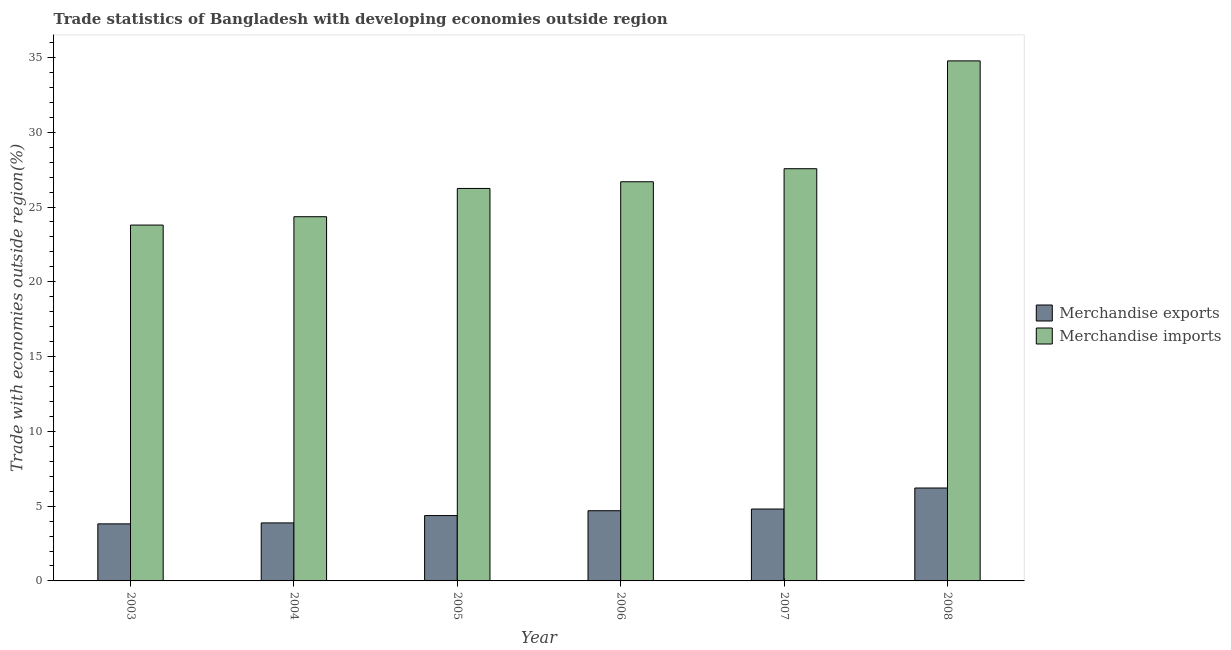How many different coloured bars are there?
Give a very brief answer. 2. Are the number of bars per tick equal to the number of legend labels?
Your response must be concise. Yes. Are the number of bars on each tick of the X-axis equal?
Keep it short and to the point. Yes. What is the merchandise imports in 2005?
Ensure brevity in your answer.  26.24. Across all years, what is the maximum merchandise imports?
Your response must be concise. 34.77. Across all years, what is the minimum merchandise imports?
Give a very brief answer. 23.79. In which year was the merchandise exports minimum?
Give a very brief answer. 2003. What is the total merchandise exports in the graph?
Offer a very short reply. 27.77. What is the difference between the merchandise imports in 2006 and that in 2007?
Offer a very short reply. -0.87. What is the difference between the merchandise exports in 2005 and the merchandise imports in 2007?
Offer a terse response. -0.44. What is the average merchandise exports per year?
Your answer should be compact. 4.63. What is the ratio of the merchandise exports in 2004 to that in 2008?
Make the answer very short. 0.62. Is the merchandise imports in 2004 less than that in 2007?
Make the answer very short. Yes. Is the difference between the merchandise exports in 2004 and 2007 greater than the difference between the merchandise imports in 2004 and 2007?
Keep it short and to the point. No. What is the difference between the highest and the second highest merchandise exports?
Provide a succinct answer. 1.41. What is the difference between the highest and the lowest merchandise imports?
Your answer should be compact. 10.98. How many bars are there?
Offer a very short reply. 12. Are all the bars in the graph horizontal?
Keep it short and to the point. No. How many years are there in the graph?
Offer a very short reply. 6. What is the difference between two consecutive major ticks on the Y-axis?
Offer a terse response. 5. Does the graph contain grids?
Offer a terse response. No. Where does the legend appear in the graph?
Your response must be concise. Center right. What is the title of the graph?
Your answer should be compact. Trade statistics of Bangladesh with developing economies outside region. Does "Male labourers" appear as one of the legend labels in the graph?
Keep it short and to the point. No. What is the label or title of the Y-axis?
Provide a short and direct response. Trade with economies outside region(%). What is the Trade with economies outside region(%) in Merchandise exports in 2003?
Ensure brevity in your answer.  3.81. What is the Trade with economies outside region(%) of Merchandise imports in 2003?
Give a very brief answer. 23.79. What is the Trade with economies outside region(%) of Merchandise exports in 2004?
Your response must be concise. 3.88. What is the Trade with economies outside region(%) of Merchandise imports in 2004?
Ensure brevity in your answer.  24.35. What is the Trade with economies outside region(%) of Merchandise exports in 2005?
Your response must be concise. 4.37. What is the Trade with economies outside region(%) in Merchandise imports in 2005?
Your response must be concise. 26.24. What is the Trade with economies outside region(%) of Merchandise exports in 2006?
Your answer should be very brief. 4.69. What is the Trade with economies outside region(%) in Merchandise imports in 2006?
Your answer should be compact. 26.69. What is the Trade with economies outside region(%) in Merchandise exports in 2007?
Keep it short and to the point. 4.81. What is the Trade with economies outside region(%) in Merchandise imports in 2007?
Your answer should be very brief. 27.56. What is the Trade with economies outside region(%) of Merchandise exports in 2008?
Make the answer very short. 6.21. What is the Trade with economies outside region(%) of Merchandise imports in 2008?
Offer a very short reply. 34.77. Across all years, what is the maximum Trade with economies outside region(%) of Merchandise exports?
Offer a terse response. 6.21. Across all years, what is the maximum Trade with economies outside region(%) in Merchandise imports?
Provide a succinct answer. 34.77. Across all years, what is the minimum Trade with economies outside region(%) of Merchandise exports?
Your answer should be very brief. 3.81. Across all years, what is the minimum Trade with economies outside region(%) of Merchandise imports?
Give a very brief answer. 23.79. What is the total Trade with economies outside region(%) in Merchandise exports in the graph?
Offer a very short reply. 27.77. What is the total Trade with economies outside region(%) in Merchandise imports in the graph?
Your answer should be compact. 163.4. What is the difference between the Trade with economies outside region(%) in Merchandise exports in 2003 and that in 2004?
Give a very brief answer. -0.06. What is the difference between the Trade with economies outside region(%) of Merchandise imports in 2003 and that in 2004?
Your response must be concise. -0.56. What is the difference between the Trade with economies outside region(%) of Merchandise exports in 2003 and that in 2005?
Your response must be concise. -0.56. What is the difference between the Trade with economies outside region(%) in Merchandise imports in 2003 and that in 2005?
Keep it short and to the point. -2.45. What is the difference between the Trade with economies outside region(%) in Merchandise exports in 2003 and that in 2006?
Keep it short and to the point. -0.88. What is the difference between the Trade with economies outside region(%) in Merchandise imports in 2003 and that in 2006?
Offer a very short reply. -2.9. What is the difference between the Trade with economies outside region(%) in Merchandise exports in 2003 and that in 2007?
Your answer should be very brief. -0.99. What is the difference between the Trade with economies outside region(%) in Merchandise imports in 2003 and that in 2007?
Ensure brevity in your answer.  -3.77. What is the difference between the Trade with economies outside region(%) of Merchandise exports in 2003 and that in 2008?
Your answer should be very brief. -2.4. What is the difference between the Trade with economies outside region(%) of Merchandise imports in 2003 and that in 2008?
Your answer should be compact. -10.98. What is the difference between the Trade with economies outside region(%) of Merchandise exports in 2004 and that in 2005?
Keep it short and to the point. -0.49. What is the difference between the Trade with economies outside region(%) of Merchandise imports in 2004 and that in 2005?
Give a very brief answer. -1.89. What is the difference between the Trade with economies outside region(%) of Merchandise exports in 2004 and that in 2006?
Provide a short and direct response. -0.81. What is the difference between the Trade with economies outside region(%) in Merchandise imports in 2004 and that in 2006?
Your answer should be very brief. -2.34. What is the difference between the Trade with economies outside region(%) of Merchandise exports in 2004 and that in 2007?
Your answer should be compact. -0.93. What is the difference between the Trade with economies outside region(%) in Merchandise imports in 2004 and that in 2007?
Your answer should be very brief. -3.21. What is the difference between the Trade with economies outside region(%) in Merchandise exports in 2004 and that in 2008?
Offer a very short reply. -2.33. What is the difference between the Trade with economies outside region(%) of Merchandise imports in 2004 and that in 2008?
Keep it short and to the point. -10.42. What is the difference between the Trade with economies outside region(%) in Merchandise exports in 2005 and that in 2006?
Offer a terse response. -0.32. What is the difference between the Trade with economies outside region(%) in Merchandise imports in 2005 and that in 2006?
Your answer should be compact. -0.45. What is the difference between the Trade with economies outside region(%) of Merchandise exports in 2005 and that in 2007?
Your answer should be very brief. -0.44. What is the difference between the Trade with economies outside region(%) in Merchandise imports in 2005 and that in 2007?
Give a very brief answer. -1.32. What is the difference between the Trade with economies outside region(%) of Merchandise exports in 2005 and that in 2008?
Provide a succinct answer. -1.84. What is the difference between the Trade with economies outside region(%) of Merchandise imports in 2005 and that in 2008?
Ensure brevity in your answer.  -8.53. What is the difference between the Trade with economies outside region(%) in Merchandise exports in 2006 and that in 2007?
Offer a terse response. -0.11. What is the difference between the Trade with economies outside region(%) in Merchandise imports in 2006 and that in 2007?
Keep it short and to the point. -0.87. What is the difference between the Trade with economies outside region(%) of Merchandise exports in 2006 and that in 2008?
Offer a terse response. -1.52. What is the difference between the Trade with economies outside region(%) of Merchandise imports in 2006 and that in 2008?
Your response must be concise. -8.08. What is the difference between the Trade with economies outside region(%) of Merchandise exports in 2007 and that in 2008?
Keep it short and to the point. -1.41. What is the difference between the Trade with economies outside region(%) in Merchandise imports in 2007 and that in 2008?
Ensure brevity in your answer.  -7.21. What is the difference between the Trade with economies outside region(%) in Merchandise exports in 2003 and the Trade with economies outside region(%) in Merchandise imports in 2004?
Keep it short and to the point. -20.54. What is the difference between the Trade with economies outside region(%) of Merchandise exports in 2003 and the Trade with economies outside region(%) of Merchandise imports in 2005?
Give a very brief answer. -22.43. What is the difference between the Trade with economies outside region(%) of Merchandise exports in 2003 and the Trade with economies outside region(%) of Merchandise imports in 2006?
Your answer should be very brief. -22.87. What is the difference between the Trade with economies outside region(%) of Merchandise exports in 2003 and the Trade with economies outside region(%) of Merchandise imports in 2007?
Your answer should be compact. -23.75. What is the difference between the Trade with economies outside region(%) of Merchandise exports in 2003 and the Trade with economies outside region(%) of Merchandise imports in 2008?
Your answer should be very brief. -30.96. What is the difference between the Trade with economies outside region(%) in Merchandise exports in 2004 and the Trade with economies outside region(%) in Merchandise imports in 2005?
Offer a terse response. -22.36. What is the difference between the Trade with economies outside region(%) of Merchandise exports in 2004 and the Trade with economies outside region(%) of Merchandise imports in 2006?
Keep it short and to the point. -22.81. What is the difference between the Trade with economies outside region(%) in Merchandise exports in 2004 and the Trade with economies outside region(%) in Merchandise imports in 2007?
Give a very brief answer. -23.68. What is the difference between the Trade with economies outside region(%) in Merchandise exports in 2004 and the Trade with economies outside region(%) in Merchandise imports in 2008?
Make the answer very short. -30.89. What is the difference between the Trade with economies outside region(%) of Merchandise exports in 2005 and the Trade with economies outside region(%) of Merchandise imports in 2006?
Offer a very short reply. -22.32. What is the difference between the Trade with economies outside region(%) of Merchandise exports in 2005 and the Trade with economies outside region(%) of Merchandise imports in 2007?
Offer a very short reply. -23.19. What is the difference between the Trade with economies outside region(%) of Merchandise exports in 2005 and the Trade with economies outside region(%) of Merchandise imports in 2008?
Your answer should be compact. -30.4. What is the difference between the Trade with economies outside region(%) in Merchandise exports in 2006 and the Trade with economies outside region(%) in Merchandise imports in 2007?
Offer a terse response. -22.87. What is the difference between the Trade with economies outside region(%) of Merchandise exports in 2006 and the Trade with economies outside region(%) of Merchandise imports in 2008?
Offer a very short reply. -30.08. What is the difference between the Trade with economies outside region(%) of Merchandise exports in 2007 and the Trade with economies outside region(%) of Merchandise imports in 2008?
Your answer should be compact. -29.96. What is the average Trade with economies outside region(%) of Merchandise exports per year?
Your answer should be compact. 4.63. What is the average Trade with economies outside region(%) of Merchandise imports per year?
Your response must be concise. 27.23. In the year 2003, what is the difference between the Trade with economies outside region(%) of Merchandise exports and Trade with economies outside region(%) of Merchandise imports?
Provide a short and direct response. -19.98. In the year 2004, what is the difference between the Trade with economies outside region(%) of Merchandise exports and Trade with economies outside region(%) of Merchandise imports?
Make the answer very short. -20.47. In the year 2005, what is the difference between the Trade with economies outside region(%) in Merchandise exports and Trade with economies outside region(%) in Merchandise imports?
Keep it short and to the point. -21.87. In the year 2006, what is the difference between the Trade with economies outside region(%) in Merchandise exports and Trade with economies outside region(%) in Merchandise imports?
Give a very brief answer. -21.99. In the year 2007, what is the difference between the Trade with economies outside region(%) in Merchandise exports and Trade with economies outside region(%) in Merchandise imports?
Keep it short and to the point. -22.75. In the year 2008, what is the difference between the Trade with economies outside region(%) of Merchandise exports and Trade with economies outside region(%) of Merchandise imports?
Ensure brevity in your answer.  -28.56. What is the ratio of the Trade with economies outside region(%) of Merchandise exports in 2003 to that in 2004?
Your answer should be compact. 0.98. What is the ratio of the Trade with economies outside region(%) in Merchandise imports in 2003 to that in 2004?
Offer a very short reply. 0.98. What is the ratio of the Trade with economies outside region(%) in Merchandise exports in 2003 to that in 2005?
Make the answer very short. 0.87. What is the ratio of the Trade with economies outside region(%) of Merchandise imports in 2003 to that in 2005?
Your answer should be very brief. 0.91. What is the ratio of the Trade with economies outside region(%) in Merchandise exports in 2003 to that in 2006?
Your answer should be very brief. 0.81. What is the ratio of the Trade with economies outside region(%) of Merchandise imports in 2003 to that in 2006?
Make the answer very short. 0.89. What is the ratio of the Trade with economies outside region(%) of Merchandise exports in 2003 to that in 2007?
Your answer should be compact. 0.79. What is the ratio of the Trade with economies outside region(%) in Merchandise imports in 2003 to that in 2007?
Ensure brevity in your answer.  0.86. What is the ratio of the Trade with economies outside region(%) in Merchandise exports in 2003 to that in 2008?
Ensure brevity in your answer.  0.61. What is the ratio of the Trade with economies outside region(%) of Merchandise imports in 2003 to that in 2008?
Give a very brief answer. 0.68. What is the ratio of the Trade with economies outside region(%) in Merchandise exports in 2004 to that in 2005?
Your answer should be very brief. 0.89. What is the ratio of the Trade with economies outside region(%) in Merchandise imports in 2004 to that in 2005?
Provide a succinct answer. 0.93. What is the ratio of the Trade with economies outside region(%) of Merchandise exports in 2004 to that in 2006?
Make the answer very short. 0.83. What is the ratio of the Trade with economies outside region(%) of Merchandise imports in 2004 to that in 2006?
Ensure brevity in your answer.  0.91. What is the ratio of the Trade with economies outside region(%) of Merchandise exports in 2004 to that in 2007?
Provide a short and direct response. 0.81. What is the ratio of the Trade with economies outside region(%) of Merchandise imports in 2004 to that in 2007?
Your response must be concise. 0.88. What is the ratio of the Trade with economies outside region(%) of Merchandise exports in 2004 to that in 2008?
Give a very brief answer. 0.62. What is the ratio of the Trade with economies outside region(%) of Merchandise imports in 2004 to that in 2008?
Keep it short and to the point. 0.7. What is the ratio of the Trade with economies outside region(%) in Merchandise imports in 2005 to that in 2006?
Keep it short and to the point. 0.98. What is the ratio of the Trade with economies outside region(%) of Merchandise exports in 2005 to that in 2007?
Keep it short and to the point. 0.91. What is the ratio of the Trade with economies outside region(%) in Merchandise imports in 2005 to that in 2007?
Provide a succinct answer. 0.95. What is the ratio of the Trade with economies outside region(%) in Merchandise exports in 2005 to that in 2008?
Ensure brevity in your answer.  0.7. What is the ratio of the Trade with economies outside region(%) in Merchandise imports in 2005 to that in 2008?
Provide a succinct answer. 0.75. What is the ratio of the Trade with economies outside region(%) of Merchandise exports in 2006 to that in 2007?
Offer a terse response. 0.98. What is the ratio of the Trade with economies outside region(%) of Merchandise imports in 2006 to that in 2007?
Make the answer very short. 0.97. What is the ratio of the Trade with economies outside region(%) of Merchandise exports in 2006 to that in 2008?
Offer a very short reply. 0.76. What is the ratio of the Trade with economies outside region(%) of Merchandise imports in 2006 to that in 2008?
Provide a succinct answer. 0.77. What is the ratio of the Trade with economies outside region(%) of Merchandise exports in 2007 to that in 2008?
Your answer should be very brief. 0.77. What is the ratio of the Trade with economies outside region(%) in Merchandise imports in 2007 to that in 2008?
Offer a terse response. 0.79. What is the difference between the highest and the second highest Trade with economies outside region(%) in Merchandise exports?
Your answer should be very brief. 1.41. What is the difference between the highest and the second highest Trade with economies outside region(%) in Merchandise imports?
Provide a succinct answer. 7.21. What is the difference between the highest and the lowest Trade with economies outside region(%) of Merchandise exports?
Provide a short and direct response. 2.4. What is the difference between the highest and the lowest Trade with economies outside region(%) of Merchandise imports?
Provide a short and direct response. 10.98. 